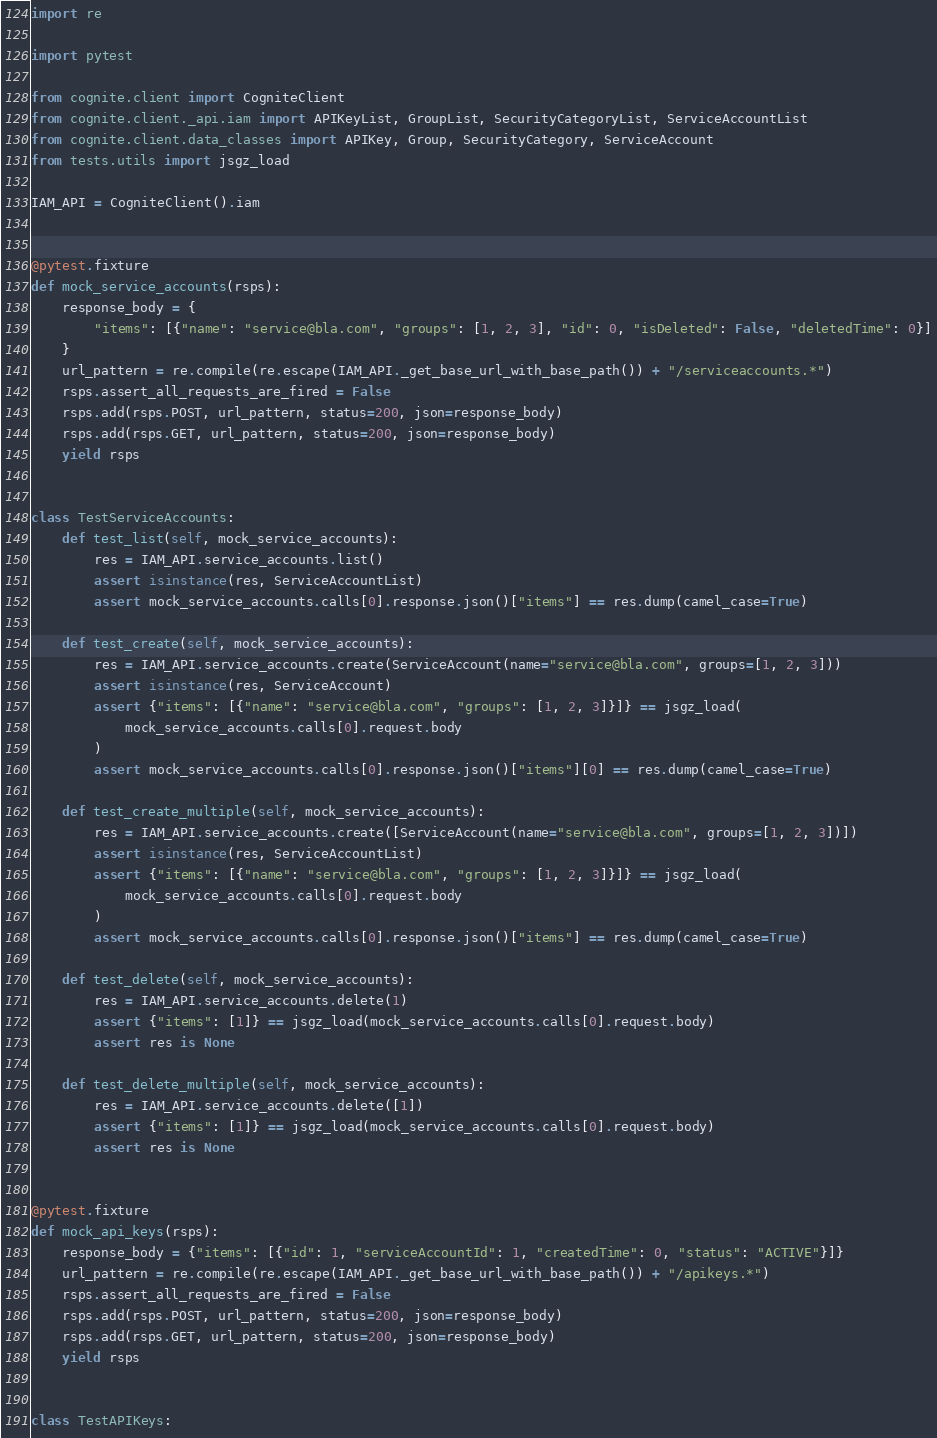<code> <loc_0><loc_0><loc_500><loc_500><_Python_>import re

import pytest

from cognite.client import CogniteClient
from cognite.client._api.iam import APIKeyList, GroupList, SecurityCategoryList, ServiceAccountList
from cognite.client.data_classes import APIKey, Group, SecurityCategory, ServiceAccount
from tests.utils import jsgz_load

IAM_API = CogniteClient().iam


@pytest.fixture
def mock_service_accounts(rsps):
    response_body = {
        "items": [{"name": "service@bla.com", "groups": [1, 2, 3], "id": 0, "isDeleted": False, "deletedTime": 0}]
    }
    url_pattern = re.compile(re.escape(IAM_API._get_base_url_with_base_path()) + "/serviceaccounts.*")
    rsps.assert_all_requests_are_fired = False
    rsps.add(rsps.POST, url_pattern, status=200, json=response_body)
    rsps.add(rsps.GET, url_pattern, status=200, json=response_body)
    yield rsps


class TestServiceAccounts:
    def test_list(self, mock_service_accounts):
        res = IAM_API.service_accounts.list()
        assert isinstance(res, ServiceAccountList)
        assert mock_service_accounts.calls[0].response.json()["items"] == res.dump(camel_case=True)

    def test_create(self, mock_service_accounts):
        res = IAM_API.service_accounts.create(ServiceAccount(name="service@bla.com", groups=[1, 2, 3]))
        assert isinstance(res, ServiceAccount)
        assert {"items": [{"name": "service@bla.com", "groups": [1, 2, 3]}]} == jsgz_load(
            mock_service_accounts.calls[0].request.body
        )
        assert mock_service_accounts.calls[0].response.json()["items"][0] == res.dump(camel_case=True)

    def test_create_multiple(self, mock_service_accounts):
        res = IAM_API.service_accounts.create([ServiceAccount(name="service@bla.com", groups=[1, 2, 3])])
        assert isinstance(res, ServiceAccountList)
        assert {"items": [{"name": "service@bla.com", "groups": [1, 2, 3]}]} == jsgz_load(
            mock_service_accounts.calls[0].request.body
        )
        assert mock_service_accounts.calls[0].response.json()["items"] == res.dump(camel_case=True)

    def test_delete(self, mock_service_accounts):
        res = IAM_API.service_accounts.delete(1)
        assert {"items": [1]} == jsgz_load(mock_service_accounts.calls[0].request.body)
        assert res is None

    def test_delete_multiple(self, mock_service_accounts):
        res = IAM_API.service_accounts.delete([1])
        assert {"items": [1]} == jsgz_load(mock_service_accounts.calls[0].request.body)
        assert res is None


@pytest.fixture
def mock_api_keys(rsps):
    response_body = {"items": [{"id": 1, "serviceAccountId": 1, "createdTime": 0, "status": "ACTIVE"}]}
    url_pattern = re.compile(re.escape(IAM_API._get_base_url_with_base_path()) + "/apikeys.*")
    rsps.assert_all_requests_are_fired = False
    rsps.add(rsps.POST, url_pattern, status=200, json=response_body)
    rsps.add(rsps.GET, url_pattern, status=200, json=response_body)
    yield rsps


class TestAPIKeys:</code> 